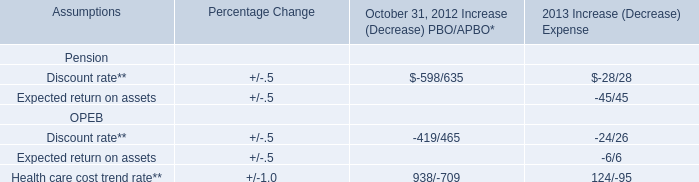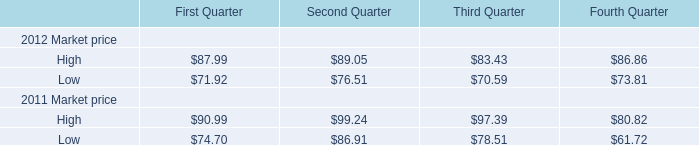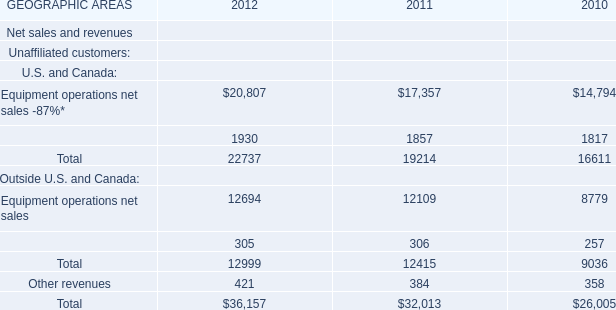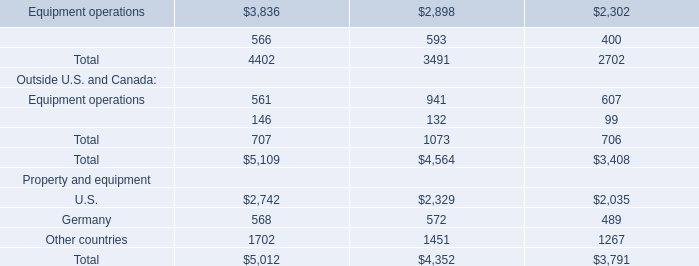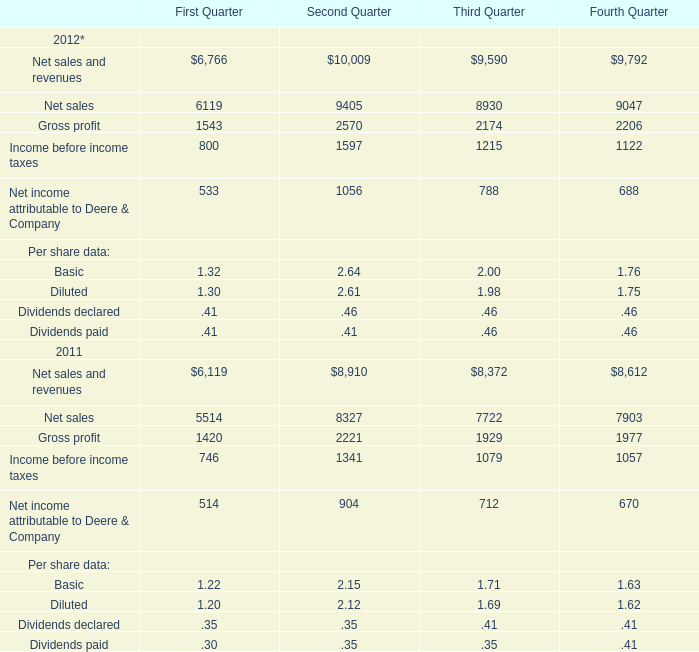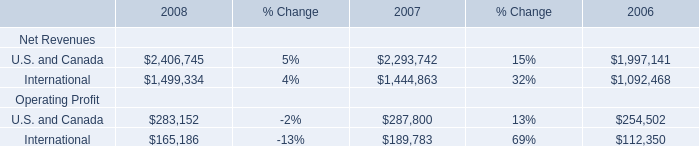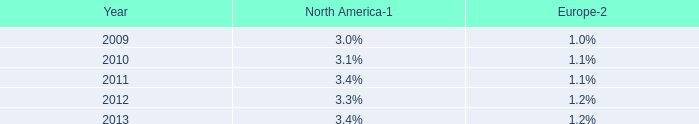What's the current growth rate of Equipment operations net sales? (in %) 
Computations: ((12694 - 12109) / 12109)
Answer: 0.04831. 